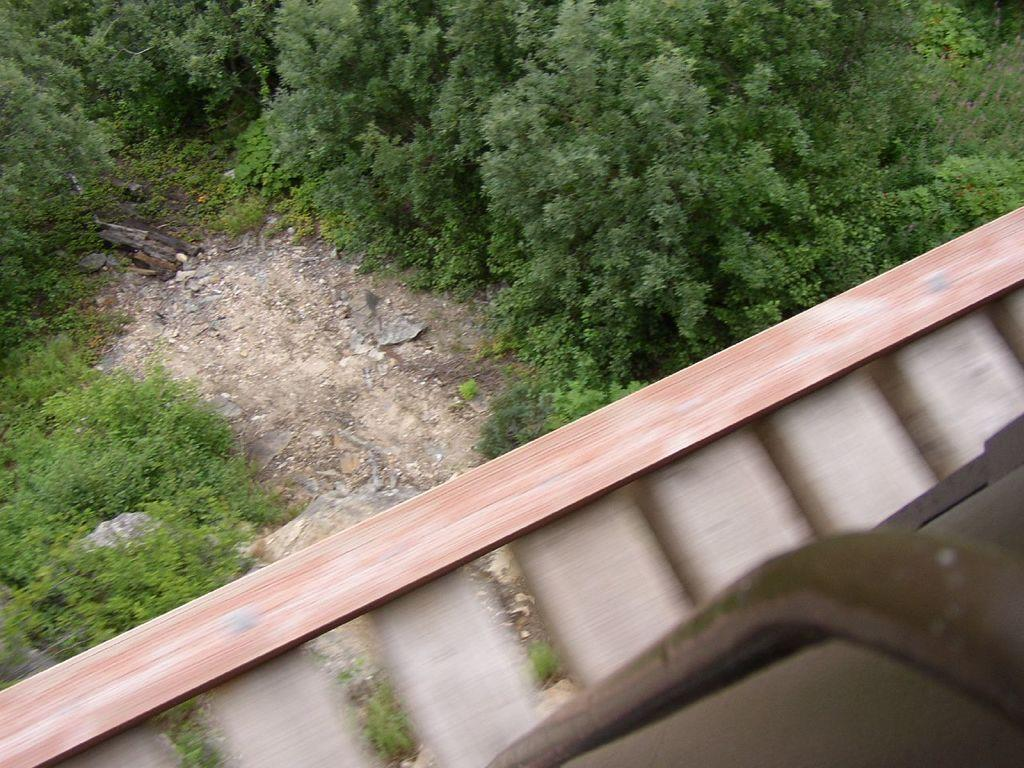What type of natural elements are present in the image? There are many trees and plants in the image. Can you describe any man-made objects in the image? Yes, there is a wooden object and a metal object in the image. How many toothbrushes are visible in the image? There are no toothbrushes present in the image. What type of plantation can be seen in the image? There is no plantation depicted in the image; it features trees and plants. 